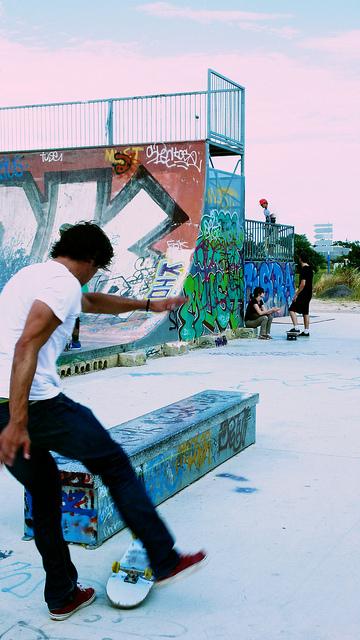What color is the man's skin?
Concise answer only. Brown. Did the man just finish a trick?
Quick response, please. Yes. Which foot does the man have on his skateboard?
Be succinct. Right. Does this man have long hair?
Short answer required. No. 